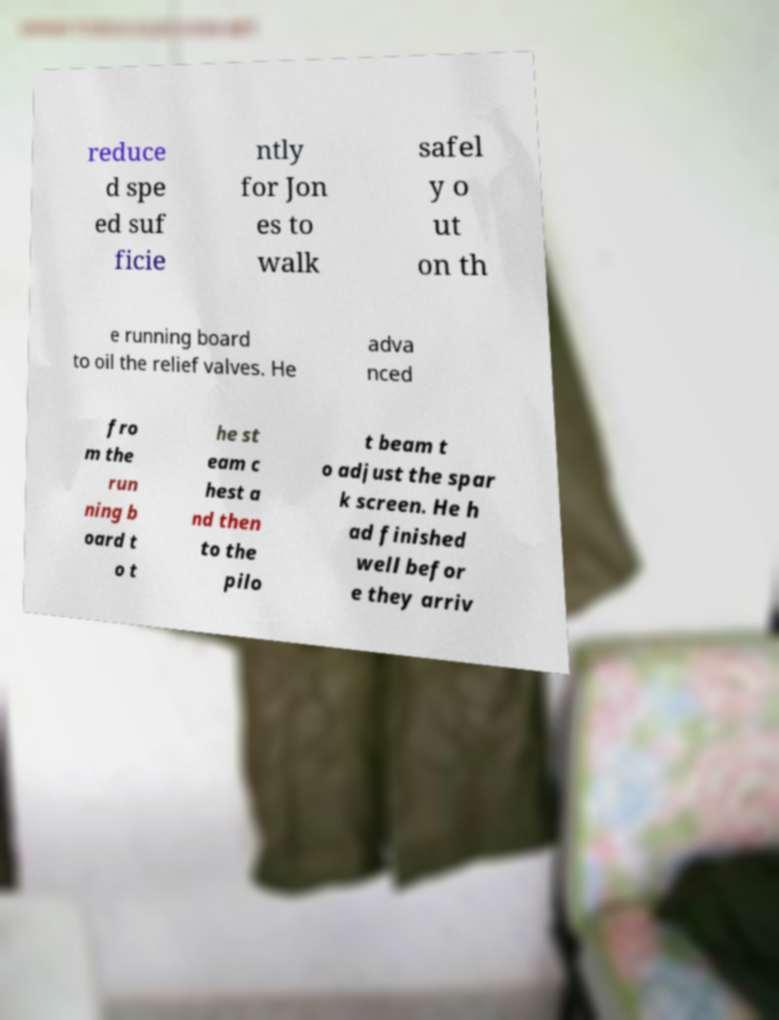Can you read and provide the text displayed in the image?This photo seems to have some interesting text. Can you extract and type it out for me? reduce d spe ed suf ficie ntly for Jon es to walk safel y o ut on th e running board to oil the relief valves. He adva nced fro m the run ning b oard t o t he st eam c hest a nd then to the pilo t beam t o adjust the spar k screen. He h ad finished well befor e they arriv 